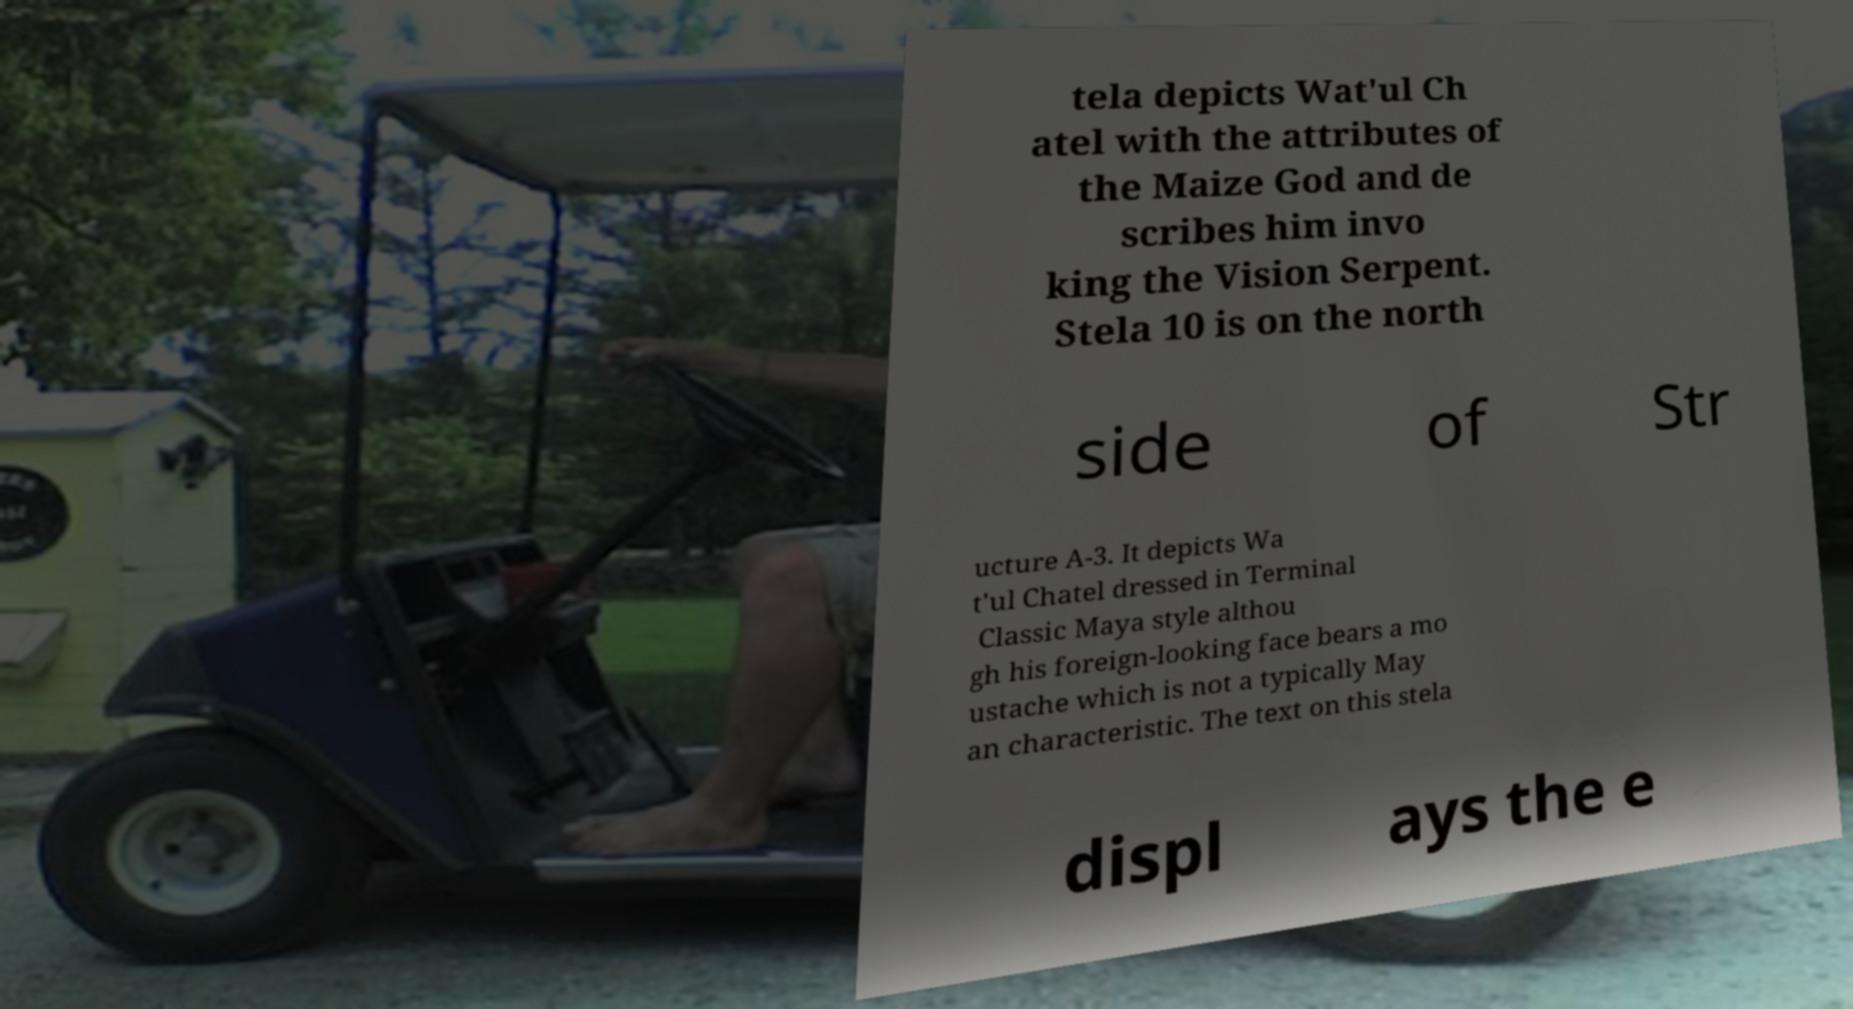Could you extract and type out the text from this image? tela depicts Wat'ul Ch atel with the attributes of the Maize God and de scribes him invo king the Vision Serpent. Stela 10 is on the north side of Str ucture A-3. It depicts Wa t'ul Chatel dressed in Terminal Classic Maya style althou gh his foreign-looking face bears a mo ustache which is not a typically May an characteristic. The text on this stela displ ays the e 